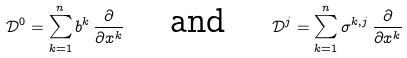<formula> <loc_0><loc_0><loc_500><loc_500>\mathcal { D } ^ { 0 } = \sum _ { k = 1 } ^ { n } b ^ { k } \, \frac { \partial } { \partial x ^ { k } } \quad \text { and } \quad \mathcal { D } ^ { j } = \sum _ { k = 1 } ^ { n } \sigma ^ { k , j } \, \frac { \partial } { \partial x ^ { k } }</formula> 